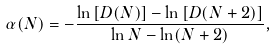Convert formula to latex. <formula><loc_0><loc_0><loc_500><loc_500>\alpha ( N ) = - \frac { \ln \left [ D ( N ) \right ] - \ln \left [ D ( N + 2 ) \right ] } { \ln N - \ln ( N + 2 ) } ,</formula> 